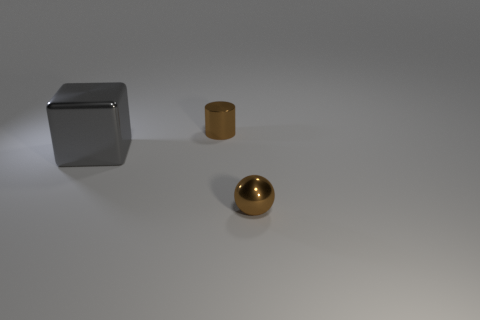Do the small metallic ball and the small shiny cylinder have the same color?
Make the answer very short. Yes. Is there a cyan block of the same size as the gray block?
Give a very brief answer. No. There is a shiny cylinder behind the large metal cube; is its size the same as the thing that is to the left of the small shiny cylinder?
Give a very brief answer. No. The small thing that is behind the thing that is in front of the large block is what shape?
Provide a succinct answer. Cylinder. There is a big gray thing; how many large gray things are behind it?
Offer a very short reply. 0. There is a large object that is the same material as the cylinder; what color is it?
Your answer should be very brief. Gray. Is the size of the brown ball the same as the brown shiny thing behind the big gray object?
Keep it short and to the point. Yes. There is a metallic object on the left side of the tiny brown metal object to the left of the thing to the right of the brown metallic cylinder; what is its size?
Provide a short and direct response. Large. What number of rubber things are either tiny brown balls or big gray cubes?
Provide a short and direct response. 0. What is the color of the thing that is to the left of the cylinder?
Make the answer very short. Gray. 